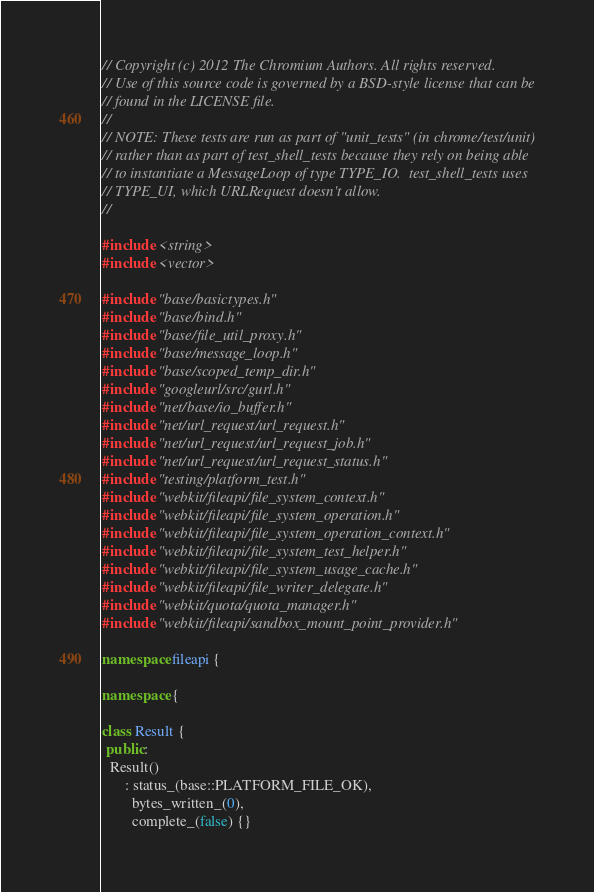Convert code to text. <code><loc_0><loc_0><loc_500><loc_500><_C++_>// Copyright (c) 2012 The Chromium Authors. All rights reserved.
// Use of this source code is governed by a BSD-style license that can be
// found in the LICENSE file.
//
// NOTE: These tests are run as part of "unit_tests" (in chrome/test/unit)
// rather than as part of test_shell_tests because they rely on being able
// to instantiate a MessageLoop of type TYPE_IO.  test_shell_tests uses
// TYPE_UI, which URLRequest doesn't allow.
//

#include <string>
#include <vector>

#include "base/basictypes.h"
#include "base/bind.h"
#include "base/file_util_proxy.h"
#include "base/message_loop.h"
#include "base/scoped_temp_dir.h"
#include "googleurl/src/gurl.h"
#include "net/base/io_buffer.h"
#include "net/url_request/url_request.h"
#include "net/url_request/url_request_job.h"
#include "net/url_request/url_request_status.h"
#include "testing/platform_test.h"
#include "webkit/fileapi/file_system_context.h"
#include "webkit/fileapi/file_system_operation.h"
#include "webkit/fileapi/file_system_operation_context.h"
#include "webkit/fileapi/file_system_test_helper.h"
#include "webkit/fileapi/file_system_usage_cache.h"
#include "webkit/fileapi/file_writer_delegate.h"
#include "webkit/quota/quota_manager.h"
#include "webkit/fileapi/sandbox_mount_point_provider.h"

namespace fileapi {

namespace {

class Result {
 public:
  Result()
      : status_(base::PLATFORM_FILE_OK),
        bytes_written_(0),
        complete_(false) {}
</code> 